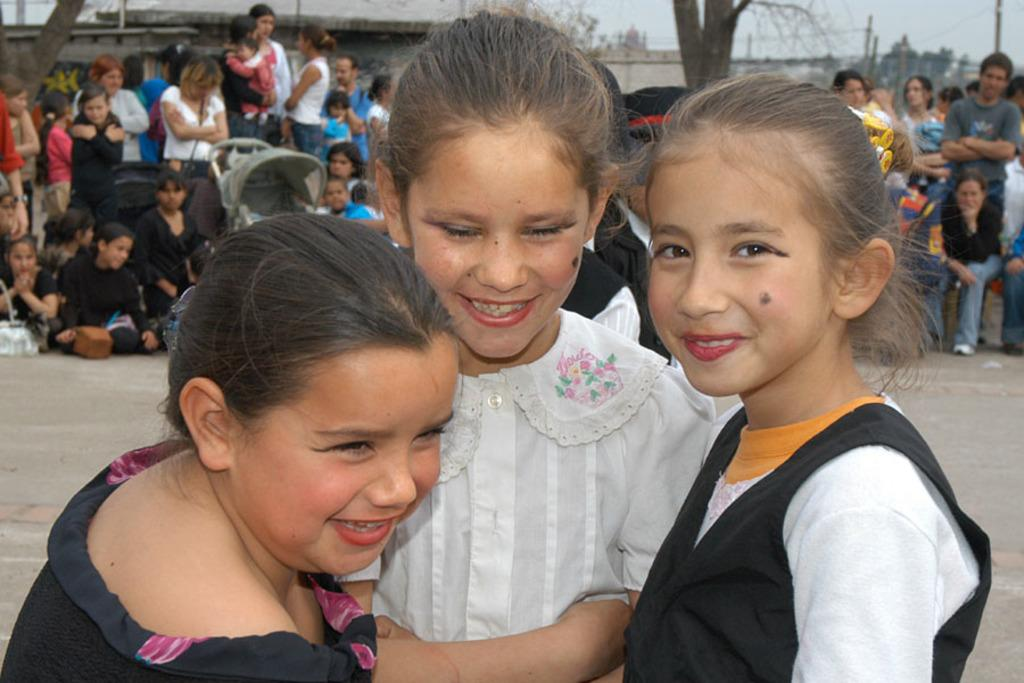How many kids are in the foreground of the image? There are three kids in the foreground of the image. What can be seen in the background of the image? There are people and trees in the background of the image. What else is visible in the background of the image? There is also a wall in the background of the image. What type of mine can be seen in the image? There is no mine present in the image. What type of plant is growing near the kids in the image? There is no plant visible near the kids in the image. 